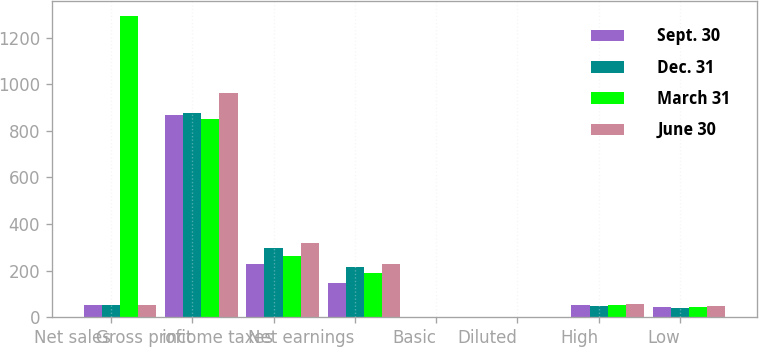Convert chart to OTSL. <chart><loc_0><loc_0><loc_500><loc_500><stacked_bar_chart><ecel><fcel>Net sales<fcel>Gross profit<fcel>income taxes<fcel>Net earnings<fcel>Basic<fcel>Diluted<fcel>High<fcel>Low<nl><fcel>Sept. 30<fcel>51<fcel>868<fcel>227.3<fcel>147.5<fcel>0.36<fcel>0.36<fcel>50.9<fcel>43.77<nl><fcel>Dec. 31<fcel>51<fcel>875.4<fcel>296.6<fcel>213.9<fcel>0.53<fcel>0.52<fcel>47.75<fcel>40.77<nl><fcel>March 31<fcel>1294<fcel>852.3<fcel>262.4<fcel>188.4<fcel>0.46<fcel>0.46<fcel>51<fcel>42.06<nl><fcel>June 30<fcel>51<fcel>961.2<fcel>317.5<fcel>227.9<fcel>0.56<fcel>0.55<fcel>55.92<fcel>48.83<nl></chart> 